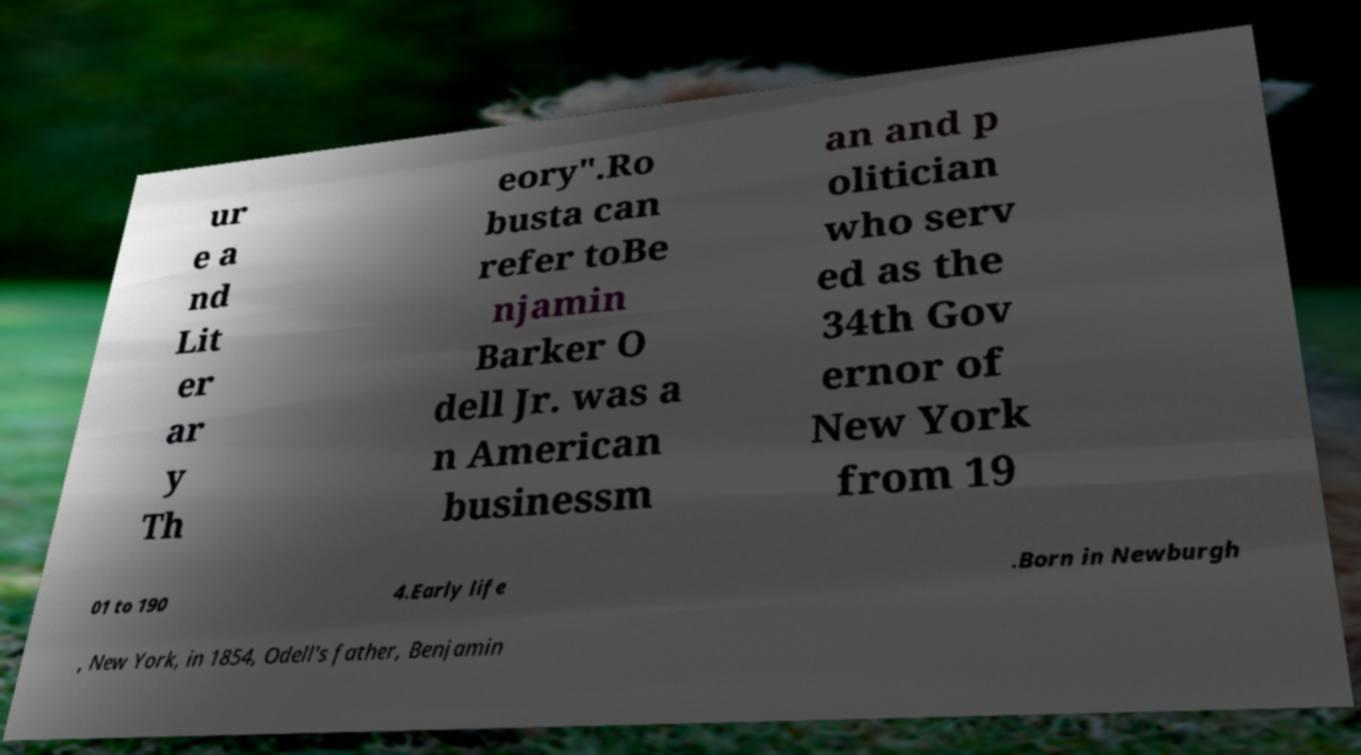Could you extract and type out the text from this image? ur e a nd Lit er ar y Th eory".Ro busta can refer toBe njamin Barker O dell Jr. was a n American businessm an and p olitician who serv ed as the 34th Gov ernor of New York from 19 01 to 190 4.Early life .Born in Newburgh , New York, in 1854, Odell's father, Benjamin 